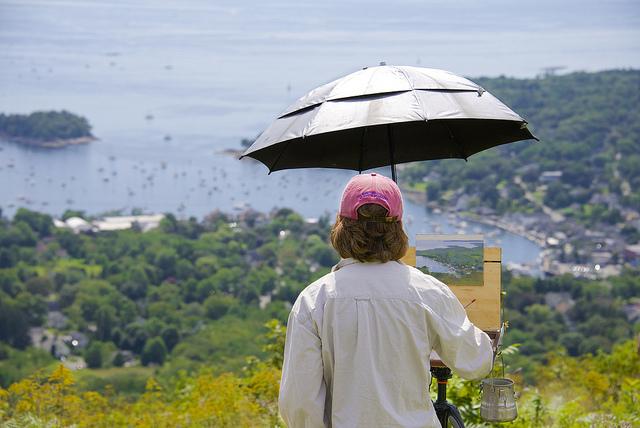Is the person on a hill?
Give a very brief answer. Yes. What color is this person's hat?
Give a very brief answer. Pink. Is it raining?
Concise answer only. No. 